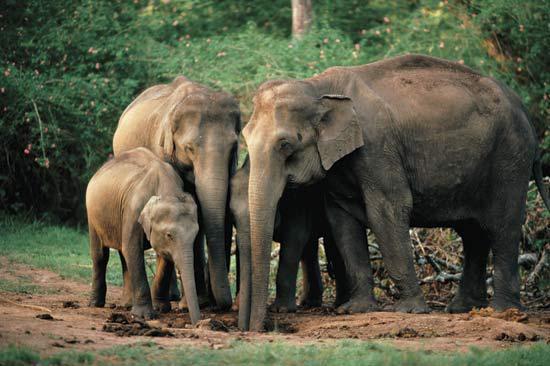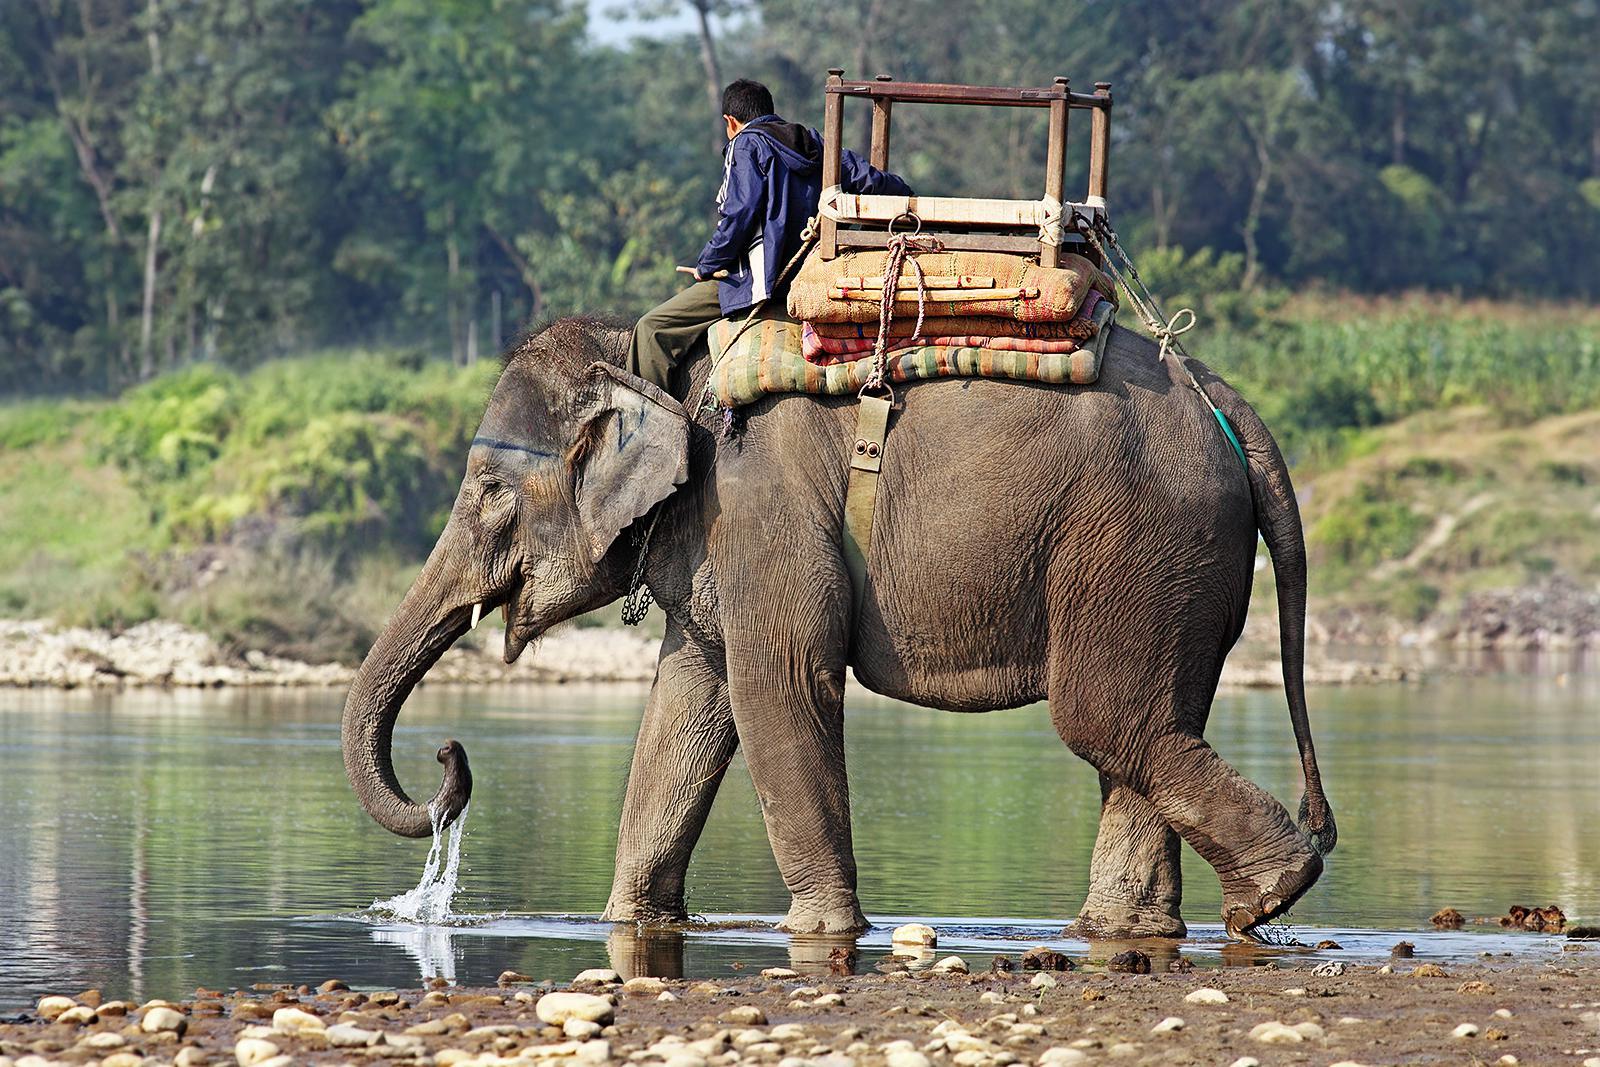The first image is the image on the left, the second image is the image on the right. For the images displayed, is the sentence "A leftward-facing elephant has a type of chair strapped to its back." factually correct? Answer yes or no. Yes. The first image is the image on the left, the second image is the image on the right. For the images displayed, is the sentence "A person is riding an elephant that is wading through water." factually correct? Answer yes or no. Yes. 